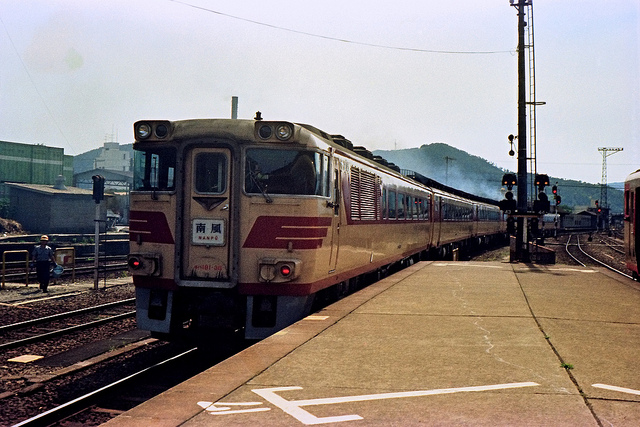<image>What is the number on the train? I don't know what the number on the train is. It's not visible and could be any of the following: '81 39', '91', '01', '2', '0', '23', '21' or 'unreadable 101 something'. What is the number on the train? I don't know what is the number on the train. It is not clear from the given answers. 